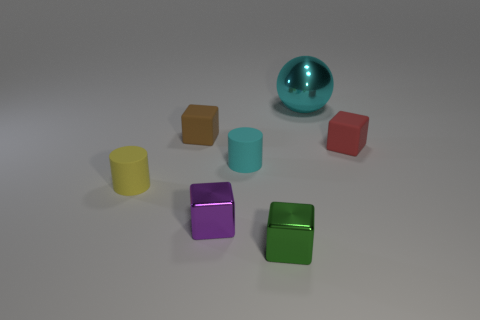Do the green object and the small cylinder that is on the right side of the purple metallic thing have the same material?
Provide a succinct answer. No. There is a cylinder that is on the right side of the tiny matte block left of the small matte cube that is to the right of the big sphere; what is its material?
Make the answer very short. Rubber. What number of cylinders have the same color as the metallic sphere?
Your answer should be compact. 1. What material is the purple thing that is the same size as the red matte object?
Your answer should be compact. Metal. There is a cube left of the purple object; are there any tiny green things on the left side of it?
Provide a succinct answer. No. What number of other objects are the same color as the large metal object?
Your answer should be very brief. 1. How big is the green metallic thing?
Your answer should be compact. Small. Are there any small brown things?
Give a very brief answer. Yes. Is the number of small brown cubes behind the large sphere greater than the number of matte cylinders that are behind the small red cube?
Your response must be concise. No. There is a tiny block that is both right of the brown rubber thing and behind the yellow thing; what material is it?
Provide a short and direct response. Rubber. 